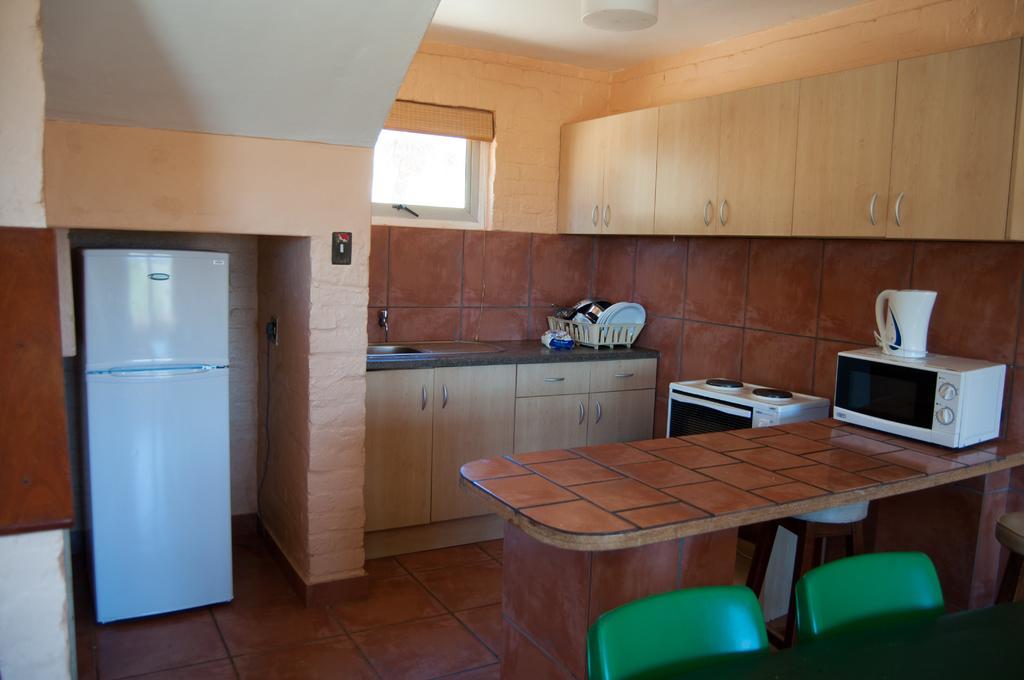How would you summarize this image in a sentence or two? This picture describes about interior of the room, in this we can find a refrigerator, chairs, table, oven, gas and cutlery, and also we can find a tap and cupboards. 